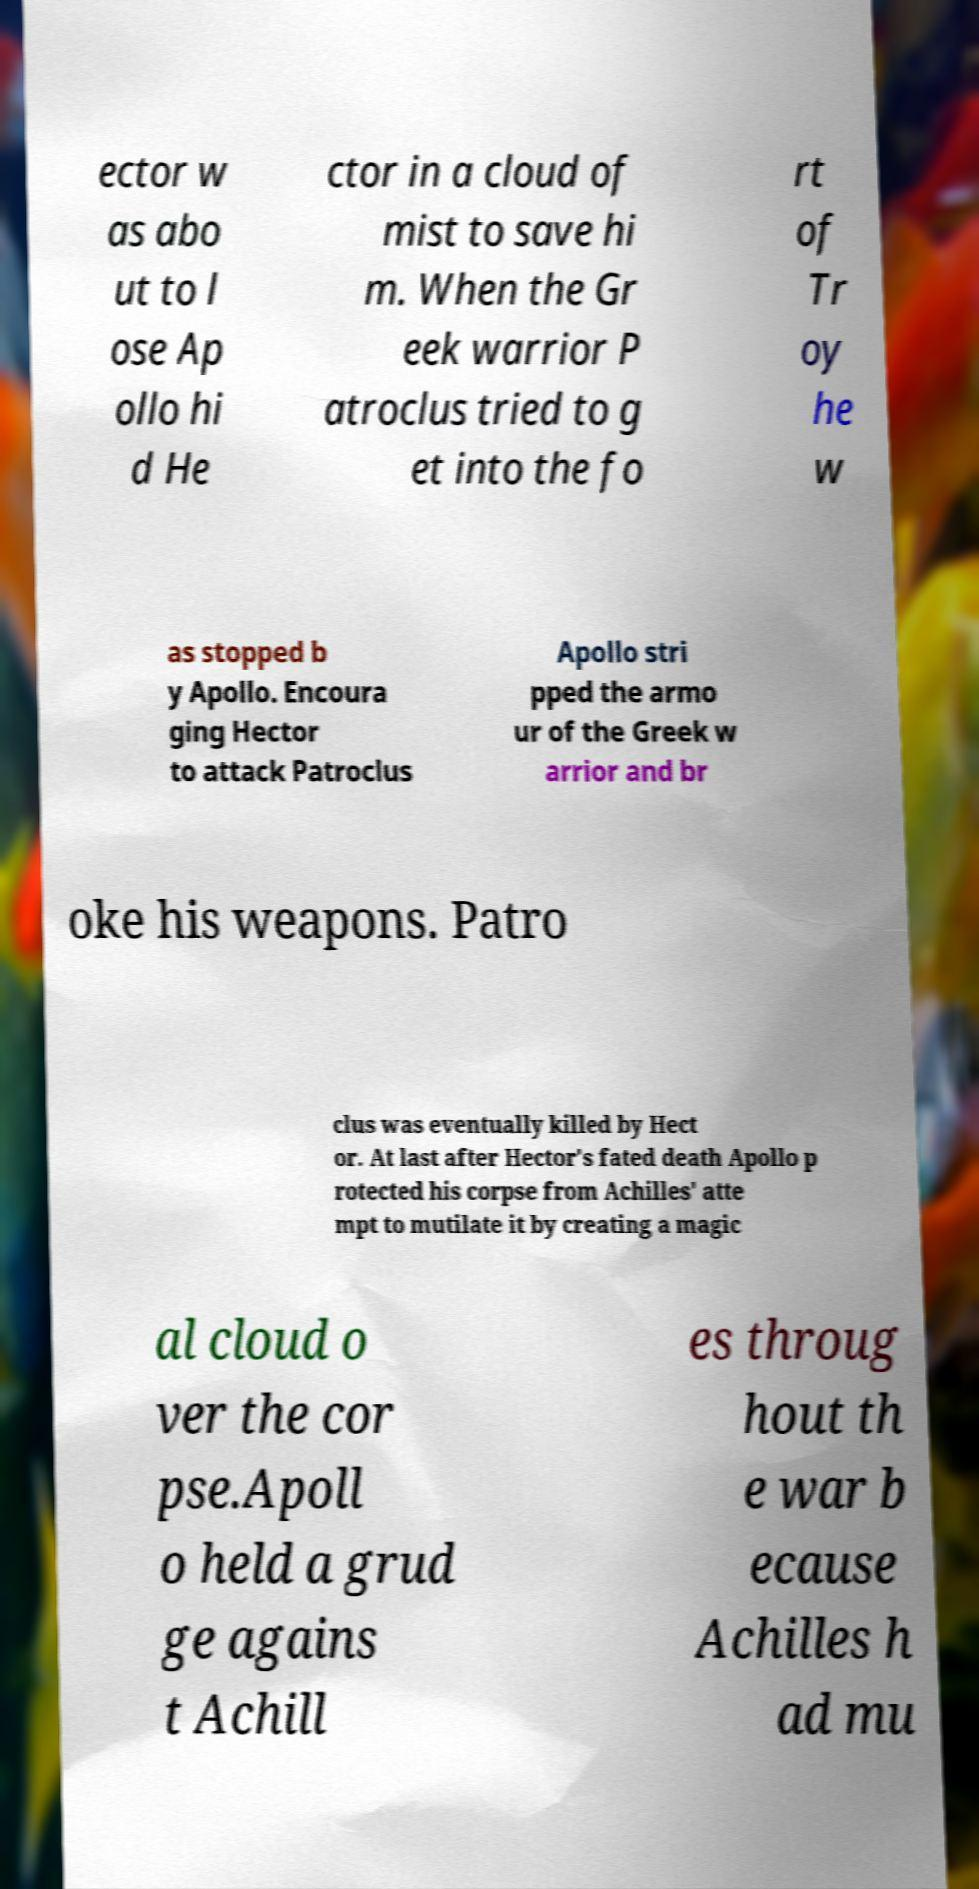I need the written content from this picture converted into text. Can you do that? ector w as abo ut to l ose Ap ollo hi d He ctor in a cloud of mist to save hi m. When the Gr eek warrior P atroclus tried to g et into the fo rt of Tr oy he w as stopped b y Apollo. Encoura ging Hector to attack Patroclus Apollo stri pped the armo ur of the Greek w arrior and br oke his weapons. Patro clus was eventually killed by Hect or. At last after Hector's fated death Apollo p rotected his corpse from Achilles' atte mpt to mutilate it by creating a magic al cloud o ver the cor pse.Apoll o held a grud ge agains t Achill es throug hout th e war b ecause Achilles h ad mu 